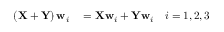<formula> <loc_0><loc_0><loc_500><loc_500>\begin{array} { r l } { \left ( X + Y \right ) w _ { i } } & = X w _ { i } + Y w _ { i } \quad i = { 1 , 2 , 3 } } \end{array}</formula> 